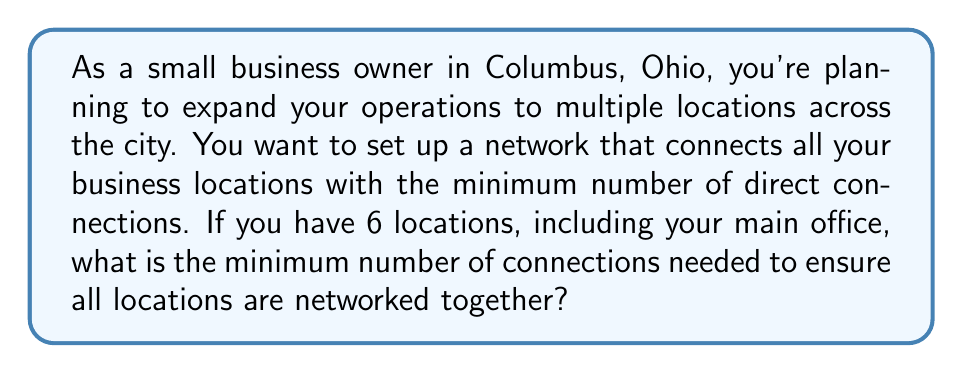Help me with this question. This problem can be solved using concepts from graph theory, specifically the idea of a minimum spanning tree.

1) First, we need to understand that each business location can be represented as a vertex in a graph, and each connection between locations as an edge.

2) The goal is to find the minimum number of edges that connect all vertices, which is equivalent to finding a spanning tree of the graph.

3) A key property of trees in graph theory is that for a tree with $n$ vertices, the number of edges is always $n-1$.

4) In this case, we have 6 locations, which means 6 vertices in our graph.

5) Therefore, the minimum number of connections (edges) needed is:

   $$\text{Number of connections} = n - 1 = 6 - 1 = 5$$

6) This solution ensures that all locations are connected (as it forms a tree) and uses the minimum number of connections possible.

7) Any fewer connections would result in at least one location being disconnected from the network.

8) Any more connections would be redundant and not minimize the number of connections.

This solution creates a network topology known as a "star" or "hub-and-spoke" network if one location (like the main office) is connected to all others, or it could be a "daisy chain" if the locations are connected in a line. The exact configuration doesn't matter as long as there are 5 connections total.
Answer: The minimum number of connections needed to network all 6 business locations is $5$. 